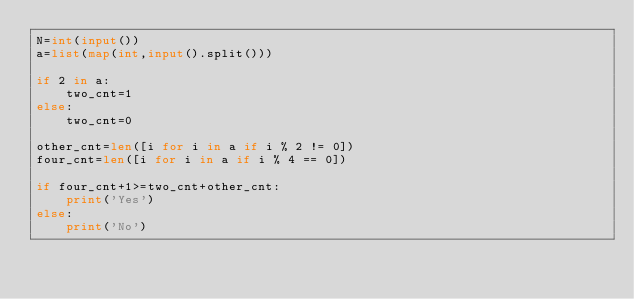Convert code to text. <code><loc_0><loc_0><loc_500><loc_500><_Python_>N=int(input())
a=list(map(int,input().split()))

if 2 in a:
    two_cnt=1
else:
    two_cnt=0

other_cnt=len([i for i in a if i % 2 != 0])
four_cnt=len([i for i in a if i % 4 == 0])

if four_cnt+1>=two_cnt+other_cnt:
    print('Yes')
else:
    print('No')</code> 